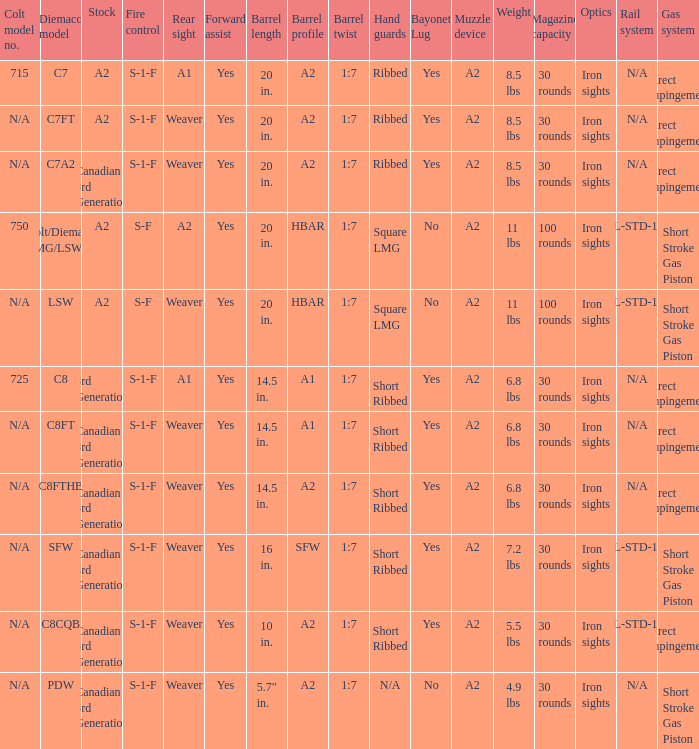Which Hand guards has a Barrel profile of a2 and a Rear sight of weaver? Ribbed, Ribbed, Short Ribbed, Short Ribbed, N/A. 